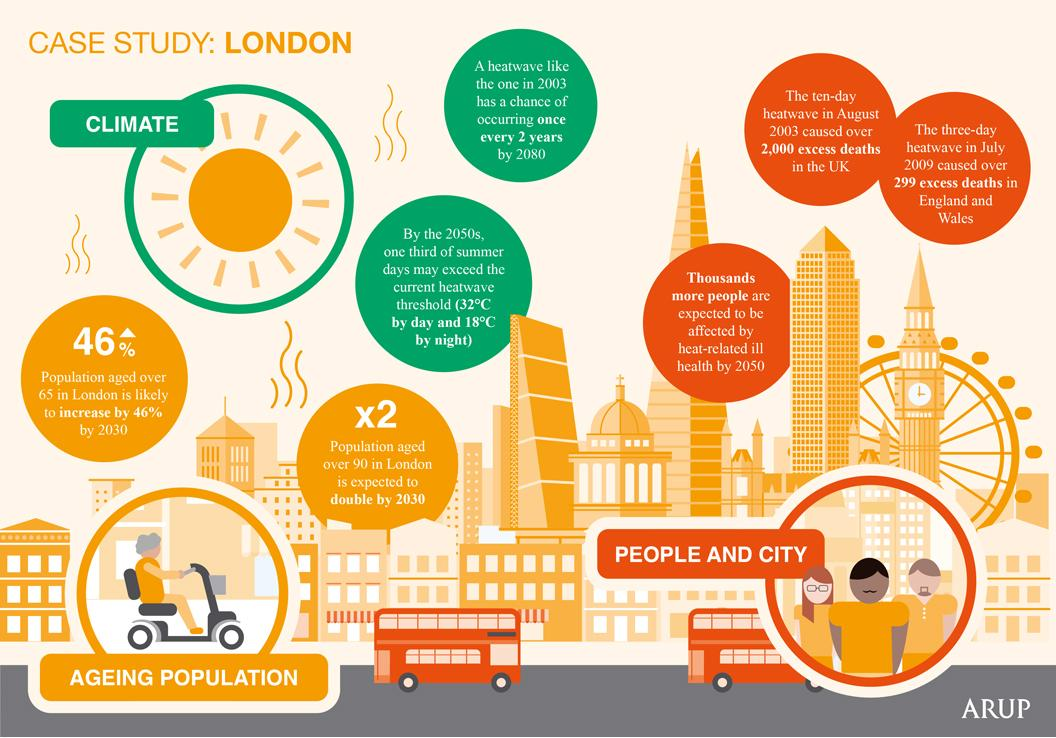Outline some significant characteristics in this image. The color codes assigned to climate are blue, green, yellow, and pink. Green is one of the colors assigned to climate. The infographic lists 2 points regarding climate. The infographic contains three points related to people and cities. The color code assigned to "People and City" is blue, green, orange, and black, with blue being the dominant color. The color code given to "Ageing Population" is yellow. 